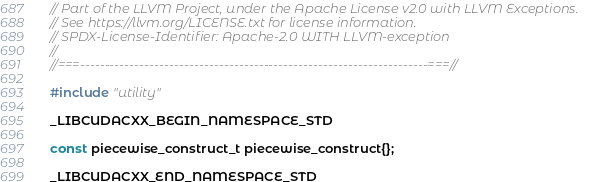<code> <loc_0><loc_0><loc_500><loc_500><_C++_>// Part of the LLVM Project, under the Apache License v2.0 with LLVM Exceptions.
// See https://llvm.org/LICENSE.txt for license information.
// SPDX-License-Identifier: Apache-2.0 WITH LLVM-exception
//
//===----------------------------------------------------------------------===//

#include "utility"

_LIBCUDACXX_BEGIN_NAMESPACE_STD

const piecewise_construct_t piecewise_construct{};

_LIBCUDACXX_END_NAMESPACE_STD
</code> 